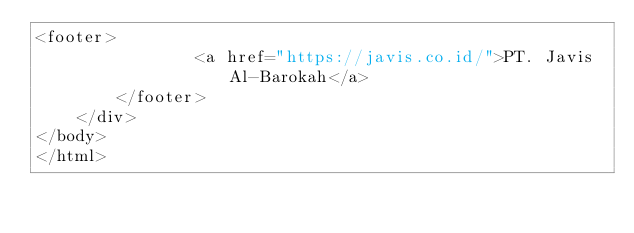Convert code to text. <code><loc_0><loc_0><loc_500><loc_500><_PHP_><footer>						
				<a href="https://javis.co.id/">PT. Javis Al-Barokah</a>			
		</footer>
	</div>
</body>
</html></code> 